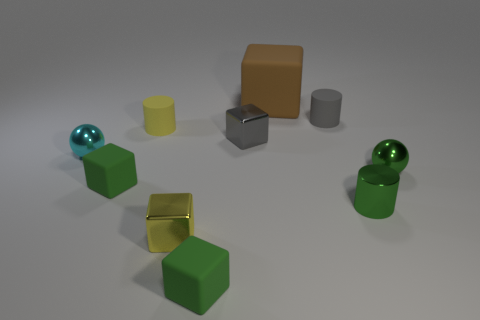How many green cubes must be subtracted to get 1 green cubes? 1 Subtract all brown matte cubes. How many cubes are left? 4 Subtract all cyan balls. How many balls are left? 1 Subtract all cylinders. How many objects are left? 7 Subtract 0 blue balls. How many objects are left? 10 Subtract 2 spheres. How many spheres are left? 0 Subtract all yellow cylinders. Subtract all gray balls. How many cylinders are left? 2 Subtract all red balls. How many yellow cubes are left? 1 Subtract all small yellow matte cylinders. Subtract all small blocks. How many objects are left? 5 Add 8 small green balls. How many small green balls are left? 9 